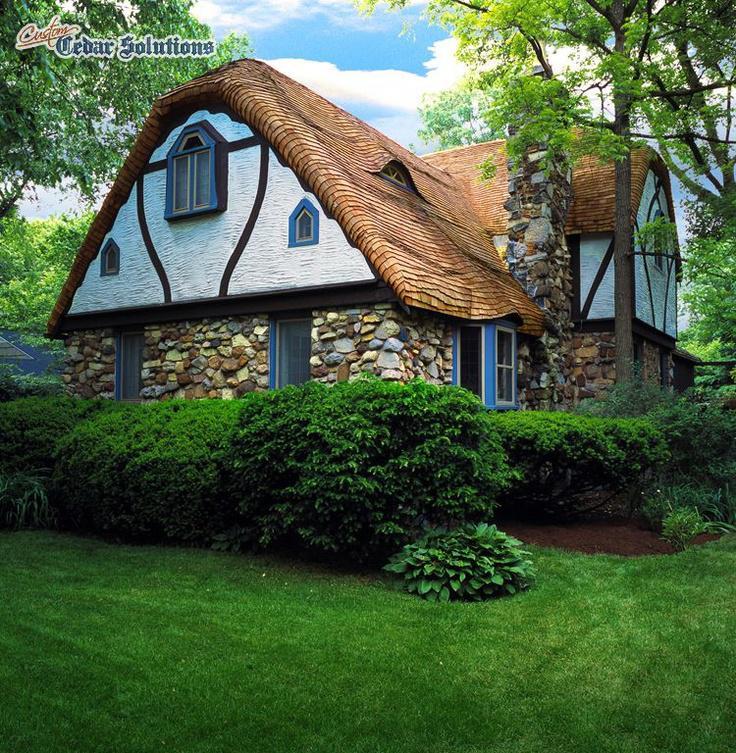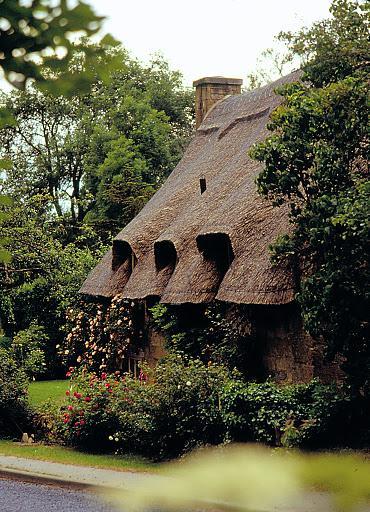The first image is the image on the left, the second image is the image on the right. Evaluate the accuracy of this statement regarding the images: "The left image shows a house with a thick gray roof covering the front and sides, topped with a chimney and a scalloped border.". Is it true? Answer yes or no. No. The first image is the image on the left, the second image is the image on the right. Assess this claim about the two images: "There is a cone shaped roof.". Correct or not? Answer yes or no. No. 